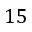Convert formula to latex. <formula><loc_0><loc_0><loc_500><loc_500>1 5</formula> 